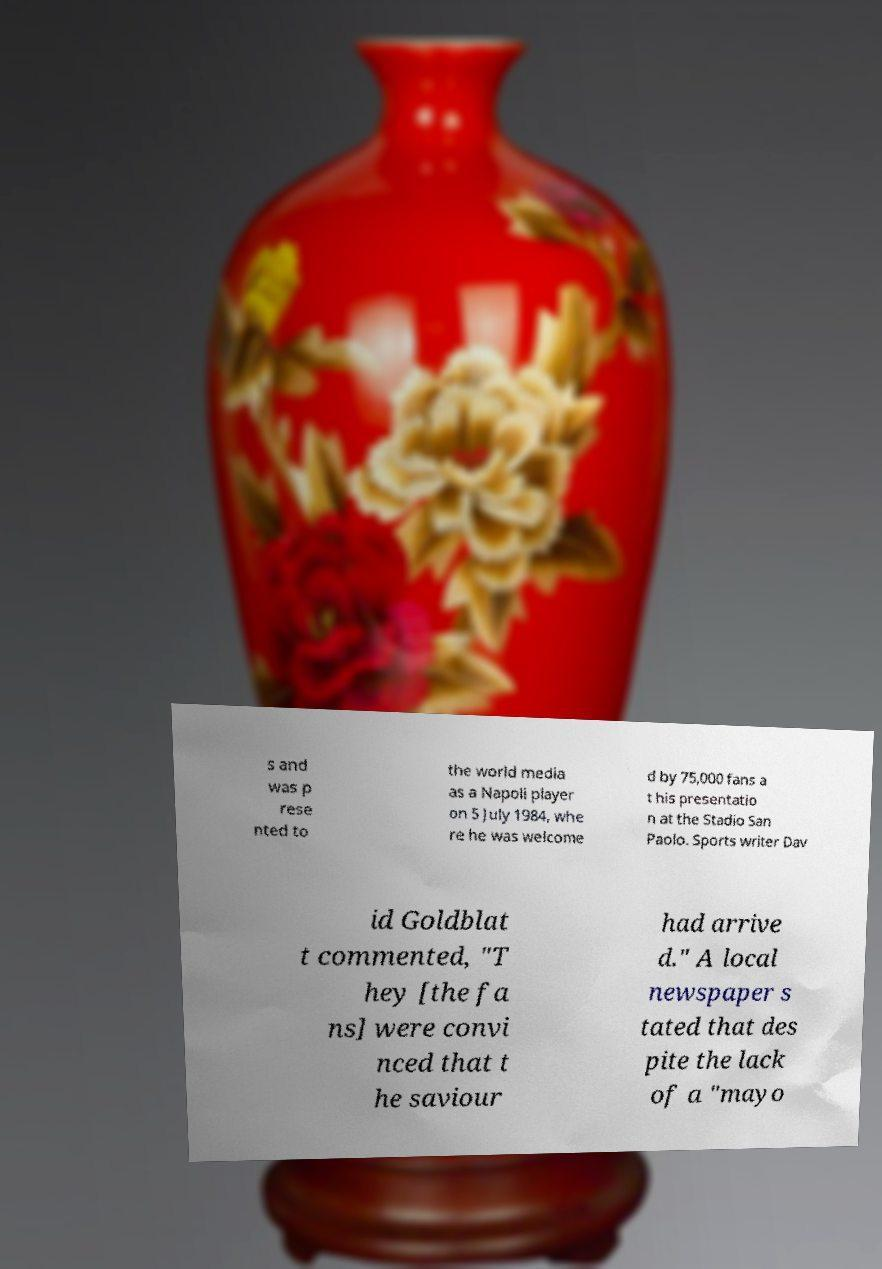For documentation purposes, I need the text within this image transcribed. Could you provide that? s and was p rese nted to the world media as a Napoli player on 5 July 1984, whe re he was welcome d by 75,000 fans a t his presentatio n at the Stadio San Paolo. Sports writer Dav id Goldblat t commented, "T hey [the fa ns] were convi nced that t he saviour had arrive d." A local newspaper s tated that des pite the lack of a "mayo 